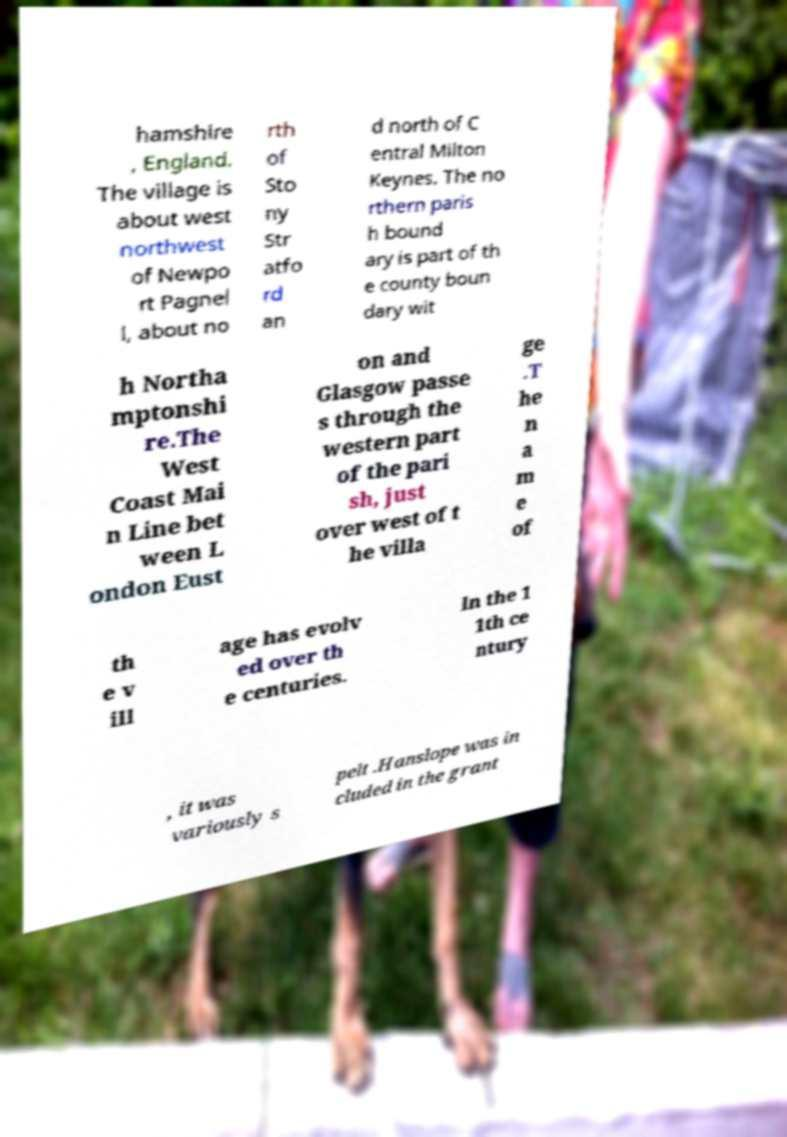What messages or text are displayed in this image? I need them in a readable, typed format. hamshire , England. The village is about west northwest of Newpo rt Pagnel l, about no rth of Sto ny Str atfo rd an d north of C entral Milton Keynes. The no rthern paris h bound ary is part of th e county boun dary wit h Northa mptonshi re.The West Coast Mai n Line bet ween L ondon Eust on and Glasgow passe s through the western part of the pari sh, just over west of t he villa ge .T he n a m e of th e v ill age has evolv ed over th e centuries. In the 1 1th ce ntury , it was variously s pelt .Hanslope was in cluded in the grant 